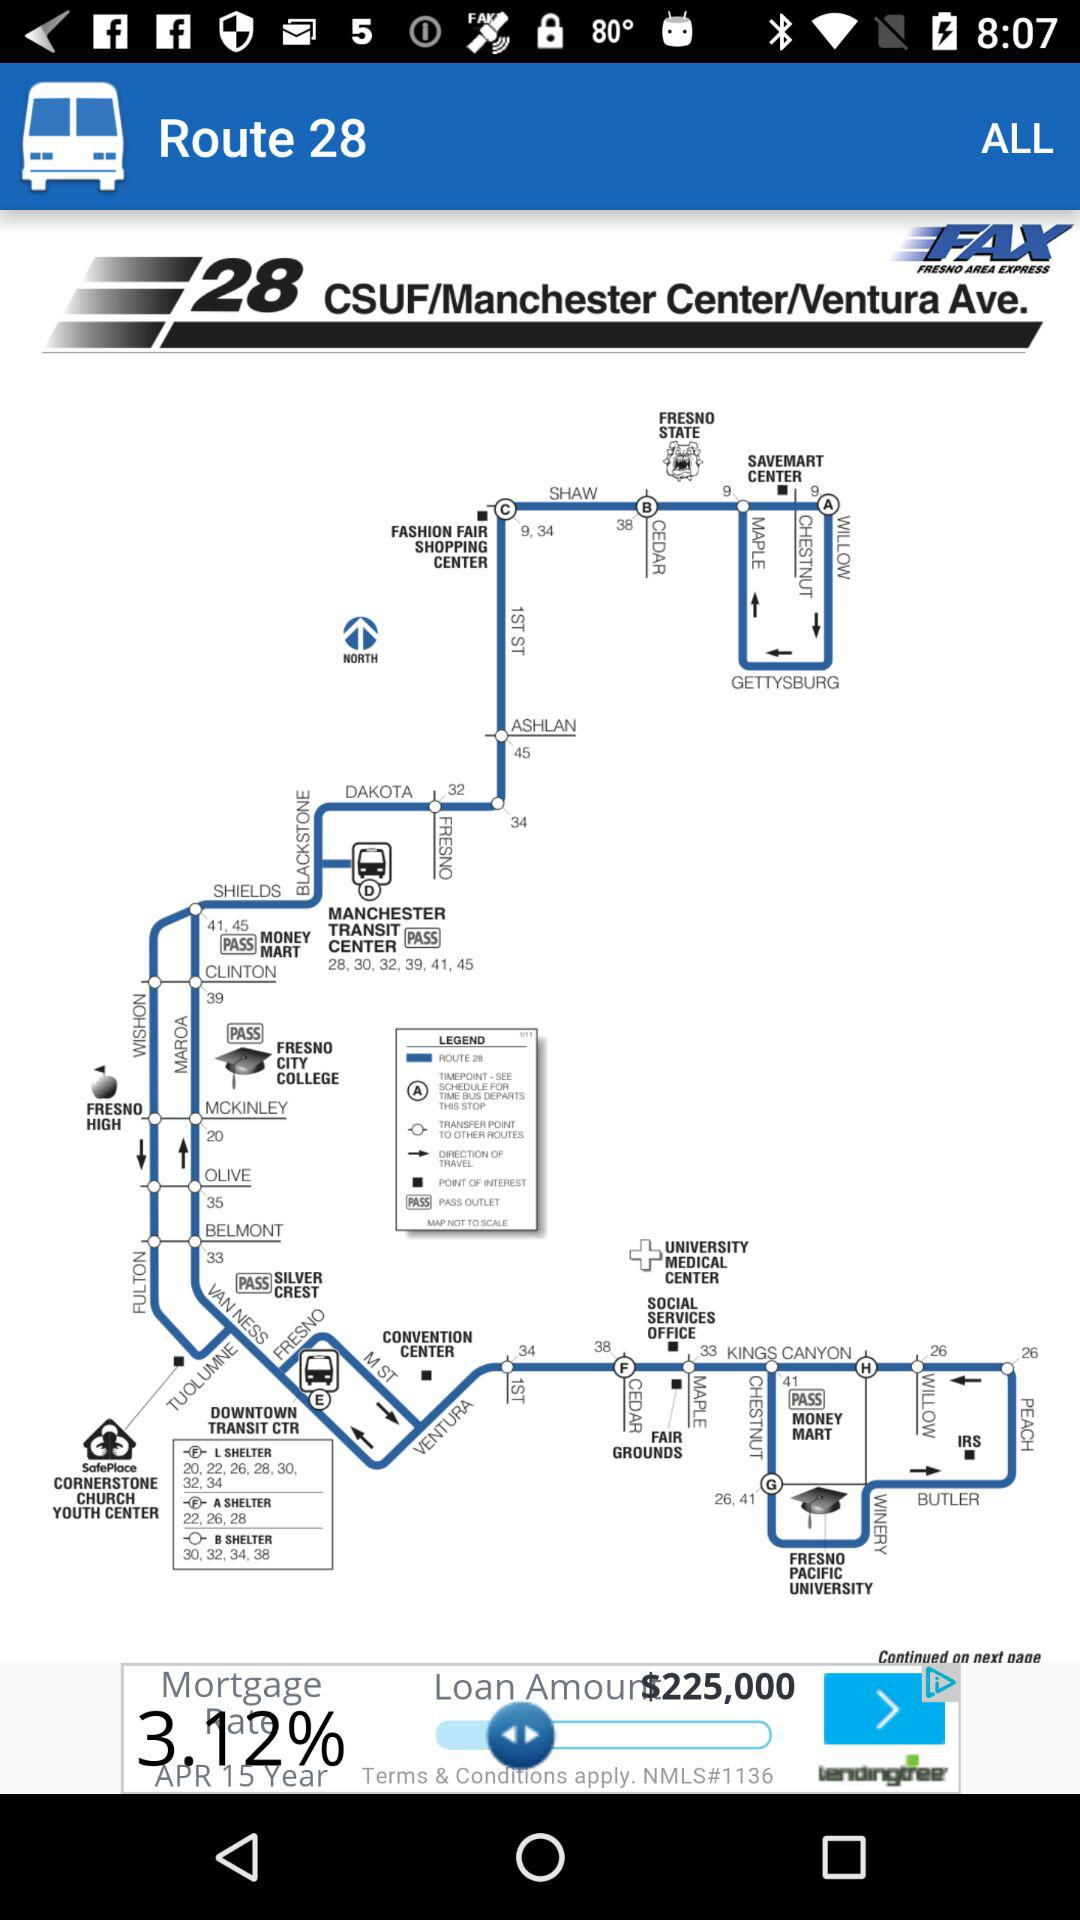What is the application name? The name of the application is "Route 28". 